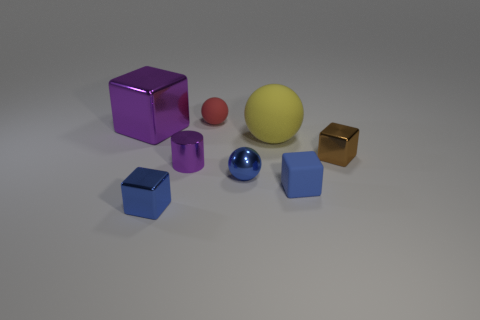Subtract all big metallic cubes. How many cubes are left? 3 Add 1 blue spheres. How many objects exist? 9 Subtract 1 cylinders. How many cylinders are left? 0 Subtract all red spheres. How many spheres are left? 2 Subtract 0 red cubes. How many objects are left? 8 Subtract all cylinders. How many objects are left? 7 Subtract all blue spheres. Subtract all green cylinders. How many spheres are left? 2 Subtract all gray balls. How many blue cubes are left? 2 Subtract all brown metal blocks. Subtract all big purple things. How many objects are left? 6 Add 1 tiny purple metal things. How many tiny purple metal things are left? 2 